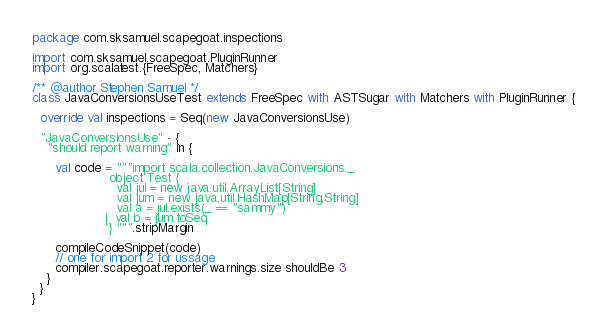Convert code to text. <code><loc_0><loc_0><loc_500><loc_500><_Scala_>package com.sksamuel.scapegoat.inspections

import com.sksamuel.scapegoat.PluginRunner
import org.scalatest.{FreeSpec, Matchers}

/** @author Stephen Samuel */
class JavaConversionsUseTest extends FreeSpec with ASTSugar with Matchers with PluginRunner {

  override val inspections = Seq(new JavaConversionsUse)

  "JavaConversionsUse" - {
    "should report warning" in {

      val code = """import scala.collection.JavaConversions._
                    object Test {
                      val jul = new java.util.ArrayList[String]
                      val jum = new java.util.HashMap[String,String]
                      val a = jul.exists(_ == "sammy")
                   |  val b = jum.toSeq
                    } """.stripMargin

      compileCodeSnippet(code)
      // one for import 2 for ussage
      compiler.scapegoat.reporter.warnings.size shouldBe 3
    }
  }
}
</code> 